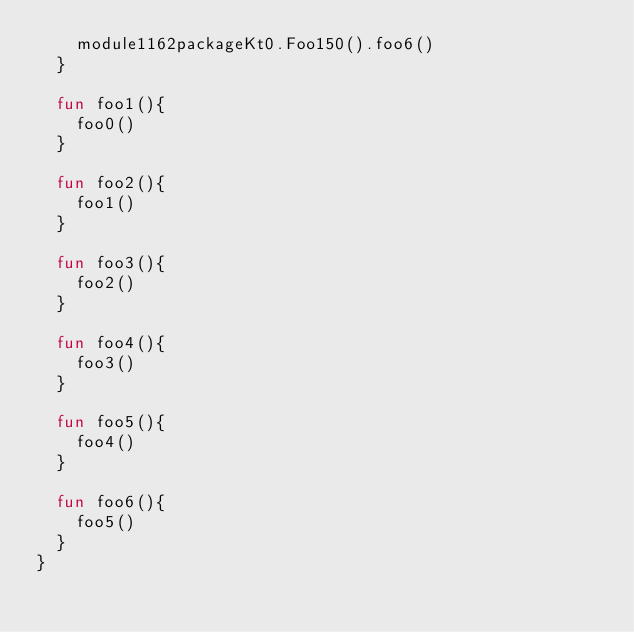<code> <loc_0><loc_0><loc_500><loc_500><_Kotlin_>    module1162packageKt0.Foo150().foo6()
  }

  fun foo1(){
    foo0()
  }

  fun foo2(){
    foo1()
  }

  fun foo3(){
    foo2()
  }

  fun foo4(){
    foo3()
  }

  fun foo5(){
    foo4()
  }

  fun foo6(){
    foo5()
  }
}</code> 